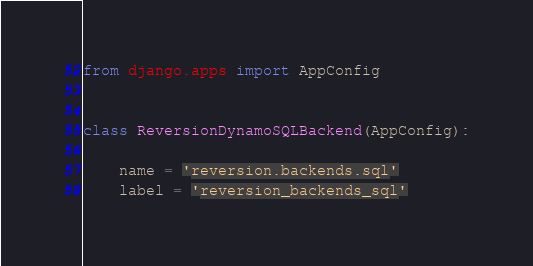Convert code to text. <code><loc_0><loc_0><loc_500><loc_500><_Python_>from django.apps import AppConfig


class ReversionDynamoSQLBackend(AppConfig):

    name = 'reversion.backends.sql'
    label = 'reversion_backends_sql'
</code> 